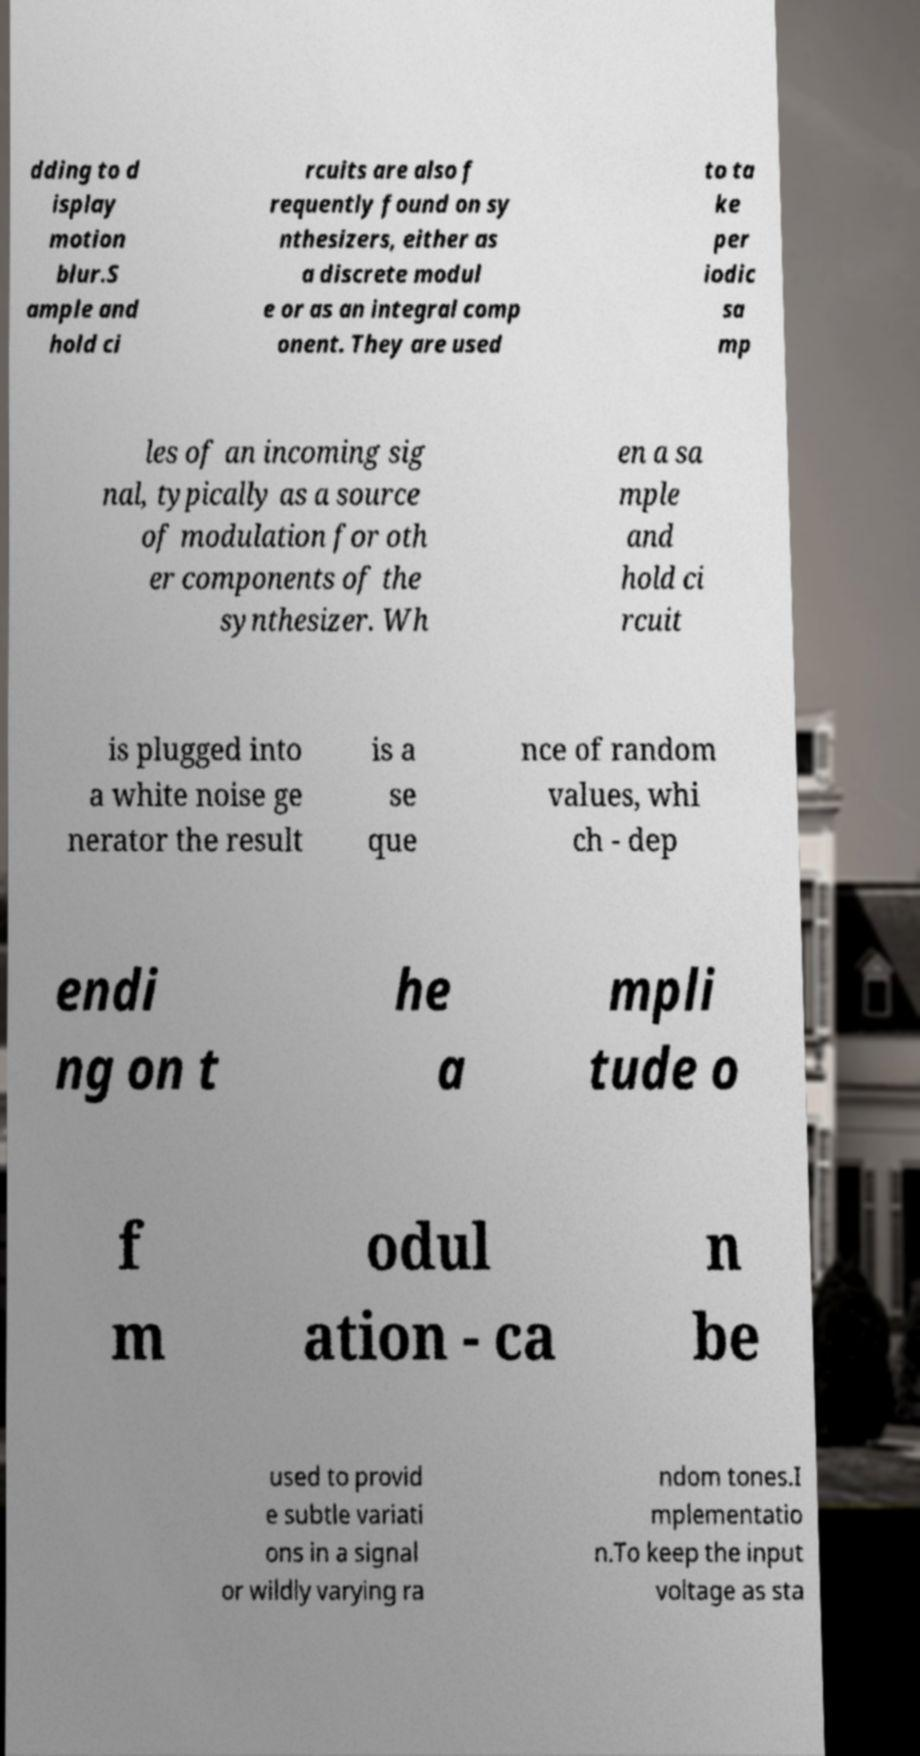For documentation purposes, I need the text within this image transcribed. Could you provide that? dding to d isplay motion blur.S ample and hold ci rcuits are also f requently found on sy nthesizers, either as a discrete modul e or as an integral comp onent. They are used to ta ke per iodic sa mp les of an incoming sig nal, typically as a source of modulation for oth er components of the synthesizer. Wh en a sa mple and hold ci rcuit is plugged into a white noise ge nerator the result is a se que nce of random values, whi ch - dep endi ng on t he a mpli tude o f m odul ation - ca n be used to provid e subtle variati ons in a signal or wildly varying ra ndom tones.I mplementatio n.To keep the input voltage as sta 